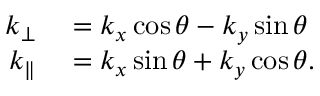<formula> <loc_0><loc_0><loc_500><loc_500>\begin{array} { r l } { k _ { \bot } } & = k _ { x } \cos \theta - k _ { y } \sin \theta } \\ { k _ { \| } } & = k _ { x } \sin \theta + k _ { y } \cos \theta . } \end{array}</formula> 